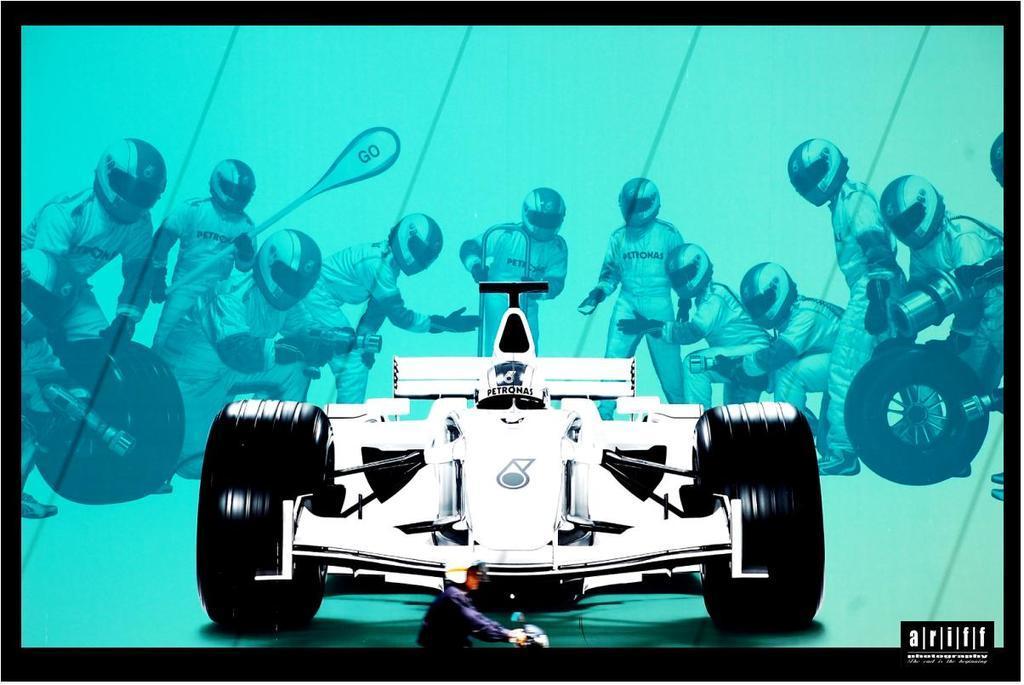Can you describe this image briefly? It is the animation image in which there is a car in the middle and there are workers around the car. They are holding the tools like tyres,rods and fitters. 